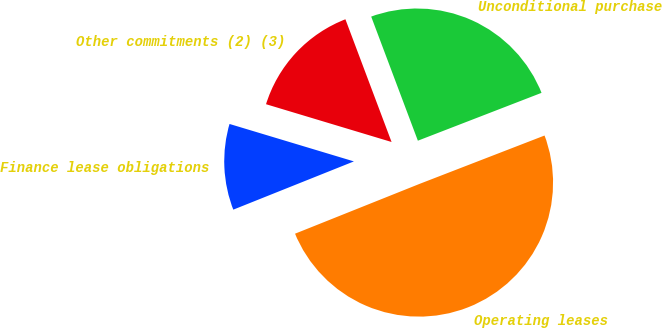Convert chart to OTSL. <chart><loc_0><loc_0><loc_500><loc_500><pie_chart><fcel>Finance lease obligations<fcel>Operating leases<fcel>Unconditional purchase<fcel>Other commitments (2) (3)<nl><fcel>10.71%<fcel>49.82%<fcel>24.85%<fcel>14.62%<nl></chart> 